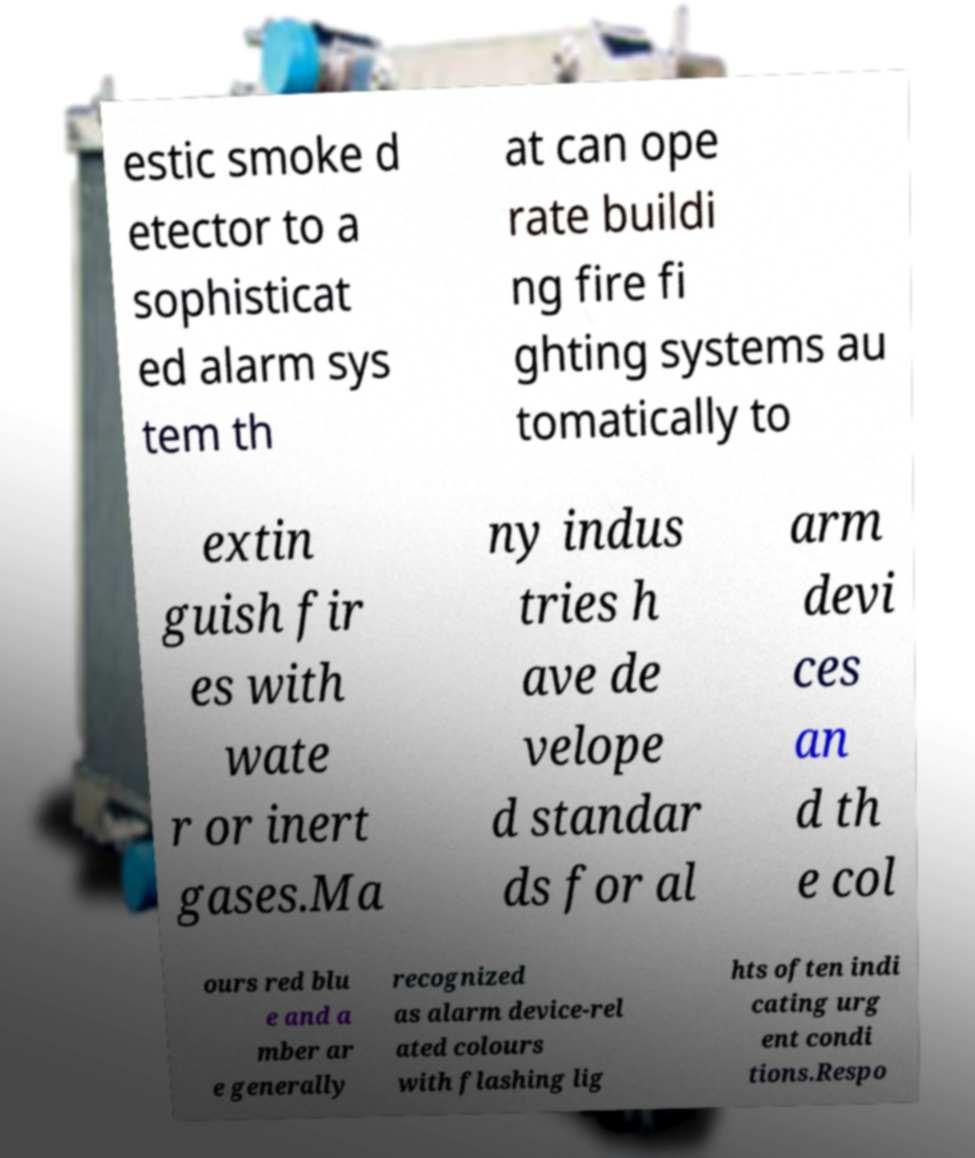Could you assist in decoding the text presented in this image and type it out clearly? estic smoke d etector to a sophisticat ed alarm sys tem th at can ope rate buildi ng fire fi ghting systems au tomatically to extin guish fir es with wate r or inert gases.Ma ny indus tries h ave de velope d standar ds for al arm devi ces an d th e col ours red blu e and a mber ar e generally recognized as alarm device-rel ated colours with flashing lig hts often indi cating urg ent condi tions.Respo 